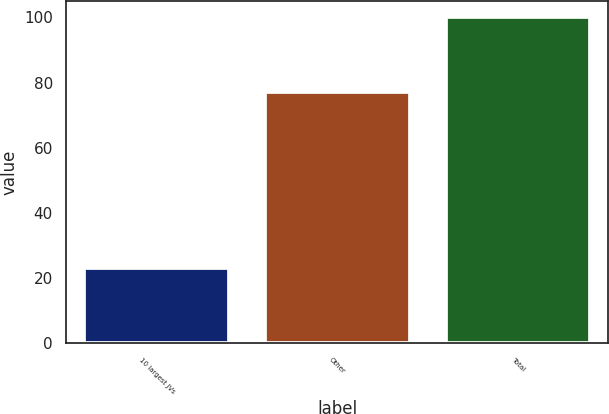<chart> <loc_0><loc_0><loc_500><loc_500><bar_chart><fcel>10 largest JVs<fcel>Other<fcel>Total<nl><fcel>23<fcel>77<fcel>100<nl></chart> 